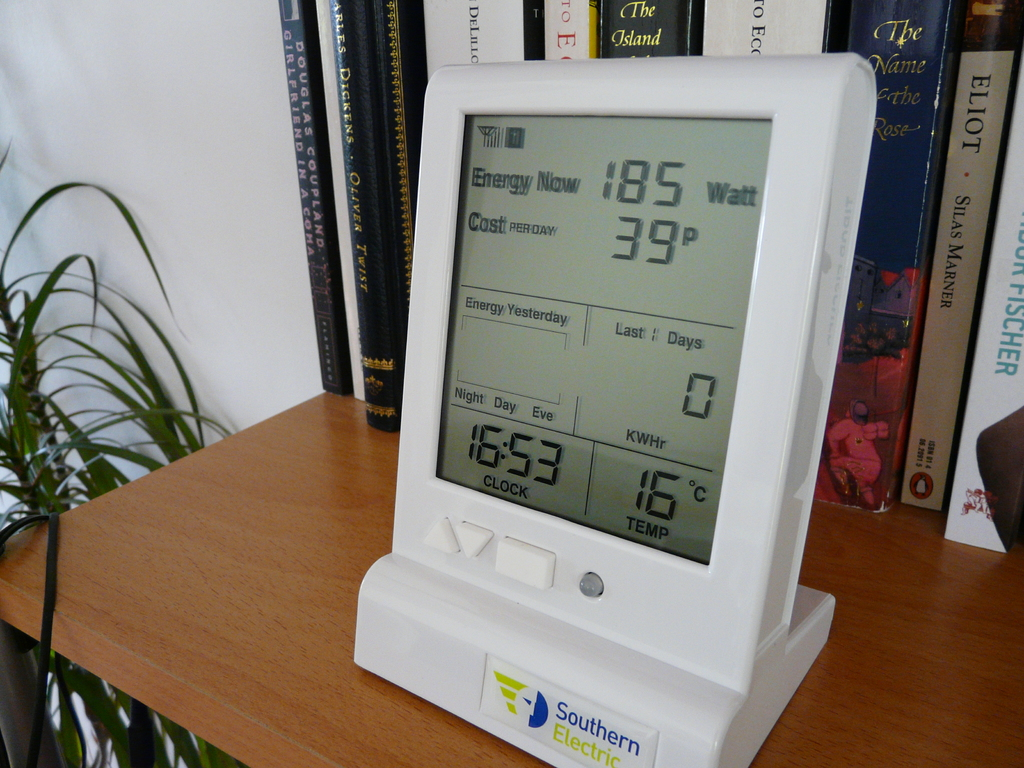What do you see happening in this image? The image reveals a detailed snapshot of an energy monitor, strategically placed among books and decorative plants on a bookshelf. This digital device displays current energy consumption at 185 Watts and the previous day's usage at 399 Watts, indicating its role in tracking daily energy metrics economically. The listed temperature is 15°C, and the time is 16:33, illustrating additional functionalities like temperature monitoring. Furthermore, the display highlights different energy costs for 'Day', 'Night', and 'Eve', suggesting adaptive tariffs that encourage energy usage when it's cheaper or less impactful on the grid. This smart device, possibly provided by Southern Electric, serves as a practical tool for monitoring energy expenditure in real-time, encouraging conscious energy usage and offering a path towards a more sustainable lifestyle. 